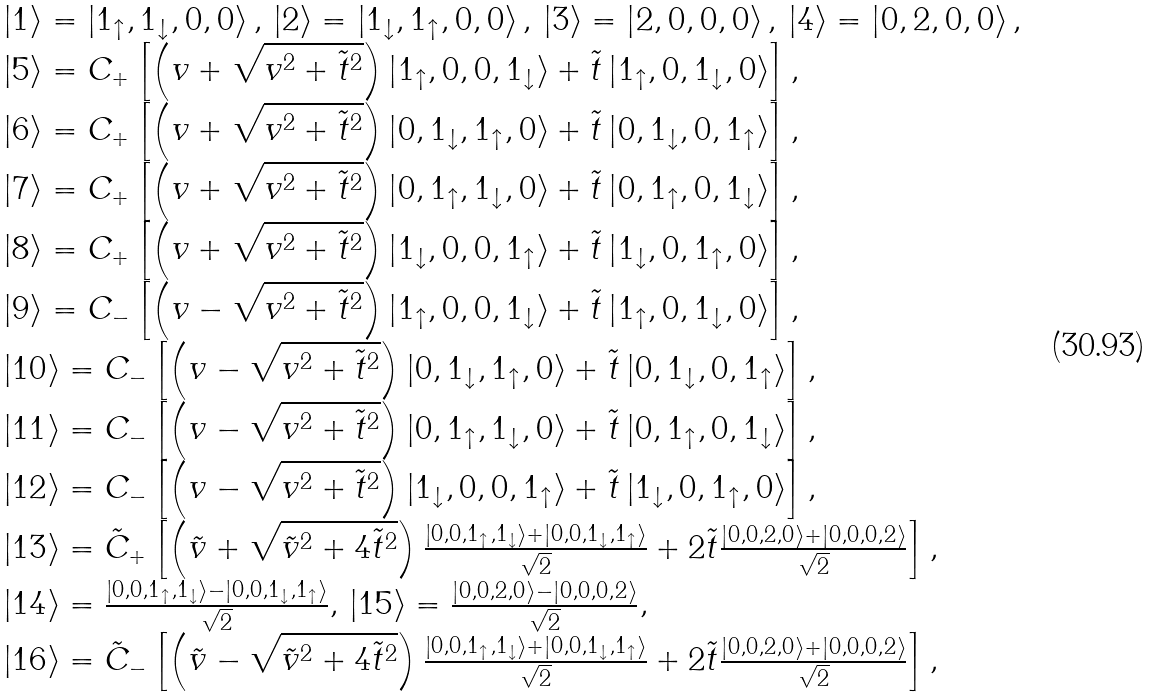<formula> <loc_0><loc_0><loc_500><loc_500>\begin{array} { l } \left | 1 \right \rangle = \left | { 1 _ { \uparrow } , 1 _ { \downarrow } , 0 , 0 } \right \rangle , \, \left | 2 \right \rangle = \left | { 1 _ { \downarrow } , 1 _ { \uparrow } , 0 , 0 } \right \rangle , \, \left | 3 \right \rangle = \left | { 2 , 0 , 0 , 0 } \right \rangle , \, \left | 4 \right \rangle = \left | { 0 , 2 , 0 , 0 } \right \rangle , \\ \left | 5 \right \rangle = C _ { + } \left [ { \left ( { v + \sqrt { v ^ { 2 } + \tilde { t } ^ { 2 } } } \right ) \left | { 1 _ { \uparrow } , 0 , 0 , 1 _ { \downarrow } } \right \rangle + \tilde { t } \left | { 1 _ { \uparrow } , 0 , 1 _ { \downarrow } , 0 } \right \rangle } \right ] , \\ \left | 6 \right \rangle = C _ { + } \left [ { \left ( { v + \sqrt { v ^ { 2 } + \tilde { t } ^ { 2 } } } \right ) \left | { 0 , 1 _ { \downarrow } , 1 _ { \uparrow } , 0 } \right \rangle + \tilde { t } \left | { 0 , 1 _ { \downarrow } , 0 , 1 _ { \uparrow } } \right \rangle } \right ] , \\ \left | 7 \right \rangle = C _ { + } \left [ { \left ( { v + \sqrt { v ^ { 2 } + \tilde { t } ^ { 2 } } } \right ) \left | { 0 , 1 _ { \uparrow } , 1 _ { \downarrow } , 0 } \right \rangle + \tilde { t } \left | { 0 , 1 _ { \uparrow } , 0 , 1 _ { \downarrow } } \right \rangle } \right ] , \\ \left | 8 \right \rangle = C _ { + } \left [ { \left ( { v + \sqrt { v ^ { 2 } + \tilde { t } ^ { 2 } } } \right ) \left | { 1 _ { \downarrow } , 0 , 0 , 1 _ { \uparrow } } \right \rangle + \tilde { t } \left | { 1 _ { \downarrow } , 0 , 1 _ { \uparrow } , 0 } \right \rangle } \right ] , \\ \left | 9 \right \rangle = C _ { - } \left [ { \left ( { v - \sqrt { v ^ { 2 } + \tilde { t } ^ { 2 } } } \right ) \left | { 1 _ { \uparrow } , 0 , 0 , 1 _ { \downarrow } } \right \rangle + \tilde { t } \left | { 1 _ { \uparrow } , 0 , 1 _ { \downarrow } , 0 } \right \rangle } \right ] , \\ \left | { 1 0 } \right \rangle = C _ { - } \left [ { \left ( { v - \sqrt { v ^ { 2 } + \tilde { t } ^ { 2 } } } \right ) \left | { 0 , 1 _ { \downarrow } , 1 _ { \uparrow } , 0 } \right \rangle + \tilde { t } \left | { 0 , 1 _ { \downarrow } , 0 , 1 _ { \uparrow } } \right \rangle } \right ] , \\ \left | { 1 1 } \right \rangle = C _ { - } \left [ { \left ( { v - \sqrt { v ^ { 2 } + \tilde { t } ^ { 2 } } } \right ) \left | { 0 , 1 _ { \uparrow } , 1 _ { \downarrow } , 0 } \right \rangle + \tilde { t } \left | { 0 , 1 _ { \uparrow } , 0 , 1 _ { \downarrow } } \right \rangle } \right ] , \\ \left | { 1 2 } \right \rangle = C _ { - } \left [ { \left ( { v - \sqrt { v ^ { 2 } + \tilde { t } ^ { 2 } } } \right ) \left | { 1 _ { \downarrow } , 0 , 0 , 1 _ { \uparrow } } \right \rangle + \tilde { t } \left | { 1 _ { \downarrow } , 0 , 1 _ { \uparrow } , 0 } \right \rangle } \right ] , \\ \left | { 1 3 } \right \rangle = \tilde { C } _ { + } \left [ { \left ( { \tilde { v } + \sqrt { \tilde { v } ^ { 2 } + 4 \tilde { t } ^ { 2 } } } \right ) \frac { { \left | { 0 , 0 , 1 _ { \uparrow } , 1 _ { \downarrow } } \right \rangle + \left | { 0 , 0 , 1 _ { \downarrow } , 1 _ { \uparrow } } \right \rangle } } { \sqrt { 2 } } + 2 \tilde { t } \frac { { \left | { 0 , 0 , 2 , 0 } \right \rangle + \left | { 0 , 0 , 0 , 2 } \right \rangle } } { \sqrt { 2 } } } \right ] , \\ \left | { 1 4 } \right \rangle = \frac { { \left | { 0 , 0 , 1 _ { \uparrow } , 1 _ { \downarrow } } \right \rangle - \left | { 0 , 0 , 1 _ { \downarrow } , 1 _ { \uparrow } } \right \rangle } } { \sqrt { 2 } } , \, \left | { 1 5 } \right \rangle = \frac { { \left | { 0 , 0 , 2 , 0 } \right \rangle - \left | { 0 , 0 , 0 , 2 } \right \rangle } } { \sqrt { 2 } } , \\ \left | { 1 6 } \right \rangle = \tilde { C } _ { - } \left [ { \left ( { \tilde { v } - \sqrt { \tilde { v } ^ { 2 } + 4 \tilde { t } ^ { 2 } } } \right ) \frac { { \left | { 0 , 0 , 1 _ { \uparrow } , 1 _ { \downarrow } } \right \rangle + \left | { 0 , 0 , 1 _ { \downarrow } , 1 _ { \uparrow } } \right \rangle } } { \sqrt { 2 } } + 2 \tilde { t } \frac { { \left | { 0 , 0 , 2 , 0 } \right \rangle + \left | { 0 , 0 , 0 , 2 } \right \rangle } } { \sqrt { 2 } } } \right ] , \\ \end{array}</formula> 